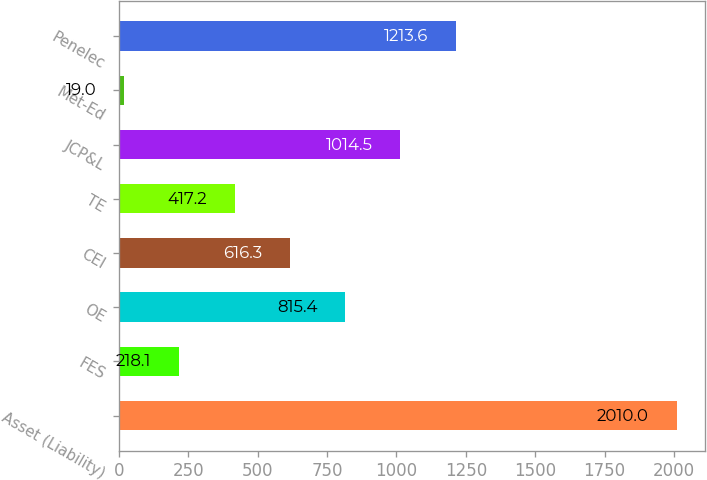<chart> <loc_0><loc_0><loc_500><loc_500><bar_chart><fcel>Asset (Liability)<fcel>FES<fcel>OE<fcel>CEI<fcel>TE<fcel>JCP&L<fcel>Met-Ed<fcel>Penelec<nl><fcel>2010<fcel>218.1<fcel>815.4<fcel>616.3<fcel>417.2<fcel>1014.5<fcel>19<fcel>1213.6<nl></chart> 